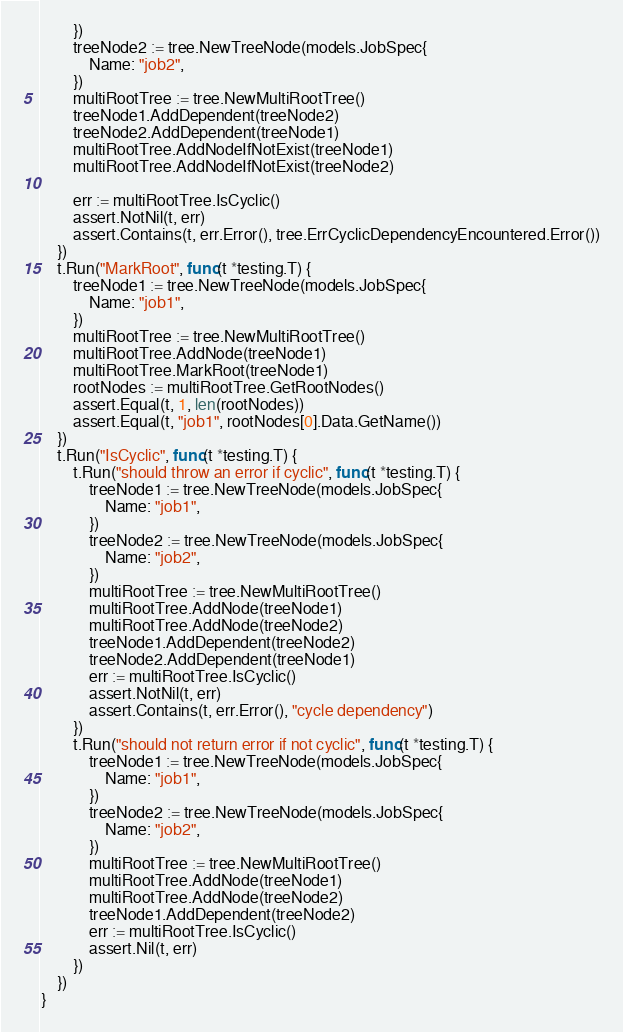<code> <loc_0><loc_0><loc_500><loc_500><_Go_>		})
		treeNode2 := tree.NewTreeNode(models.JobSpec{
			Name: "job2",
		})
		multiRootTree := tree.NewMultiRootTree()
		treeNode1.AddDependent(treeNode2)
		treeNode2.AddDependent(treeNode1)
		multiRootTree.AddNodeIfNotExist(treeNode1)
		multiRootTree.AddNodeIfNotExist(treeNode2)

		err := multiRootTree.IsCyclic()
		assert.NotNil(t, err)
		assert.Contains(t, err.Error(), tree.ErrCyclicDependencyEncountered.Error())
	})
	t.Run("MarkRoot", func(t *testing.T) {
		treeNode1 := tree.NewTreeNode(models.JobSpec{
			Name: "job1",
		})
		multiRootTree := tree.NewMultiRootTree()
		multiRootTree.AddNode(treeNode1)
		multiRootTree.MarkRoot(treeNode1)
		rootNodes := multiRootTree.GetRootNodes()
		assert.Equal(t, 1, len(rootNodes))
		assert.Equal(t, "job1", rootNodes[0].Data.GetName())
	})
	t.Run("IsCyclic", func(t *testing.T) {
		t.Run("should throw an error if cyclic", func(t *testing.T) {
			treeNode1 := tree.NewTreeNode(models.JobSpec{
				Name: "job1",
			})
			treeNode2 := tree.NewTreeNode(models.JobSpec{
				Name: "job2",
			})
			multiRootTree := tree.NewMultiRootTree()
			multiRootTree.AddNode(treeNode1)
			multiRootTree.AddNode(treeNode2)
			treeNode1.AddDependent(treeNode2)
			treeNode2.AddDependent(treeNode1)
			err := multiRootTree.IsCyclic()
			assert.NotNil(t, err)
			assert.Contains(t, err.Error(), "cycle dependency")
		})
		t.Run("should not return error if not cyclic", func(t *testing.T) {
			treeNode1 := tree.NewTreeNode(models.JobSpec{
				Name: "job1",
			})
			treeNode2 := tree.NewTreeNode(models.JobSpec{
				Name: "job2",
			})
			multiRootTree := tree.NewMultiRootTree()
			multiRootTree.AddNode(treeNode1)
			multiRootTree.AddNode(treeNode2)
			treeNode1.AddDependent(treeNode2)
			err := multiRootTree.IsCyclic()
			assert.Nil(t, err)
		})
	})
}
</code> 